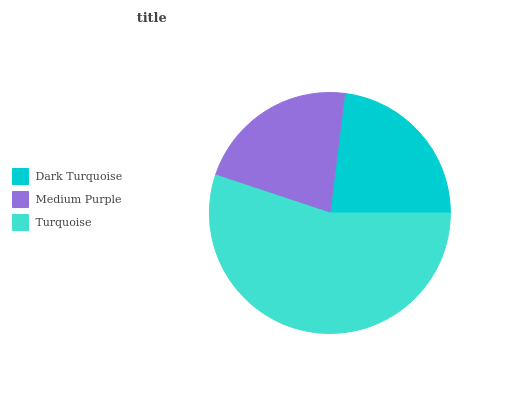Is Medium Purple the minimum?
Answer yes or no. Yes. Is Turquoise the maximum?
Answer yes or no. Yes. Is Turquoise the minimum?
Answer yes or no. No. Is Medium Purple the maximum?
Answer yes or no. No. Is Turquoise greater than Medium Purple?
Answer yes or no. Yes. Is Medium Purple less than Turquoise?
Answer yes or no. Yes. Is Medium Purple greater than Turquoise?
Answer yes or no. No. Is Turquoise less than Medium Purple?
Answer yes or no. No. Is Dark Turquoise the high median?
Answer yes or no. Yes. Is Dark Turquoise the low median?
Answer yes or no. Yes. Is Turquoise the high median?
Answer yes or no. No. Is Turquoise the low median?
Answer yes or no. No. 